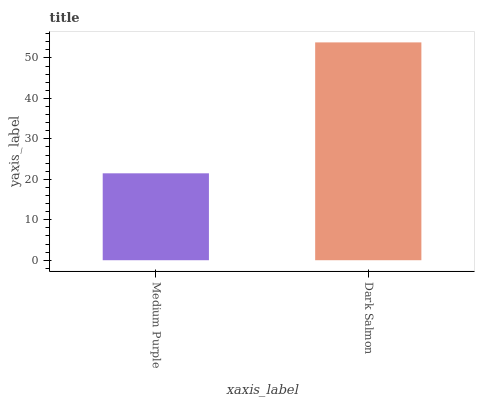Is Medium Purple the minimum?
Answer yes or no. Yes. Is Dark Salmon the maximum?
Answer yes or no. Yes. Is Dark Salmon the minimum?
Answer yes or no. No. Is Dark Salmon greater than Medium Purple?
Answer yes or no. Yes. Is Medium Purple less than Dark Salmon?
Answer yes or no. Yes. Is Medium Purple greater than Dark Salmon?
Answer yes or no. No. Is Dark Salmon less than Medium Purple?
Answer yes or no. No. Is Dark Salmon the high median?
Answer yes or no. Yes. Is Medium Purple the low median?
Answer yes or no. Yes. Is Medium Purple the high median?
Answer yes or no. No. Is Dark Salmon the low median?
Answer yes or no. No. 